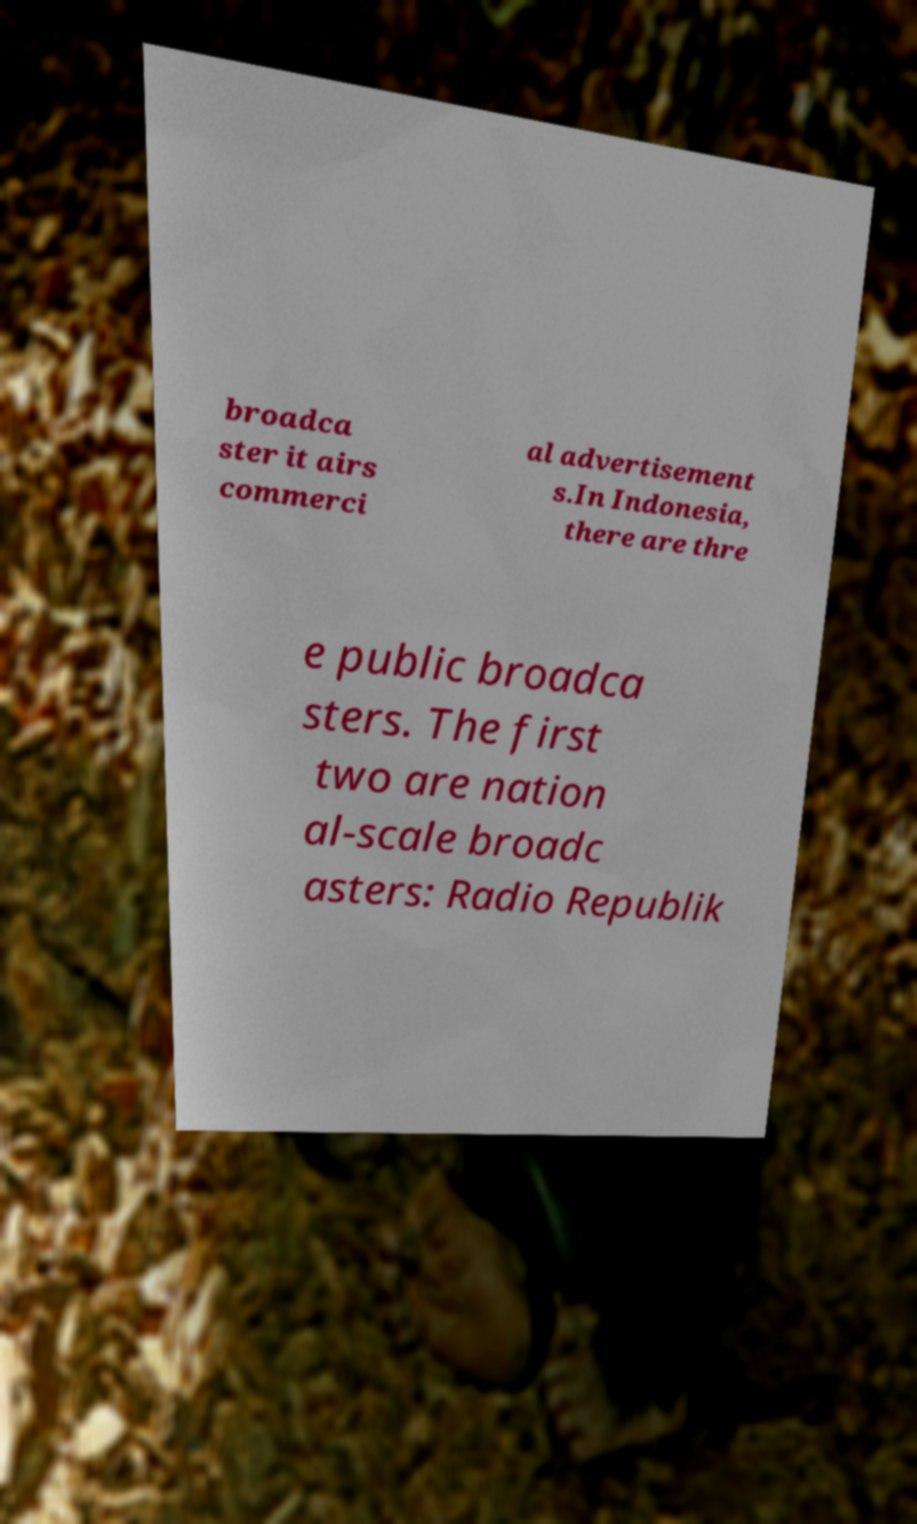Could you extract and type out the text from this image? broadca ster it airs commerci al advertisement s.In Indonesia, there are thre e public broadca sters. The first two are nation al-scale broadc asters: Radio Republik 